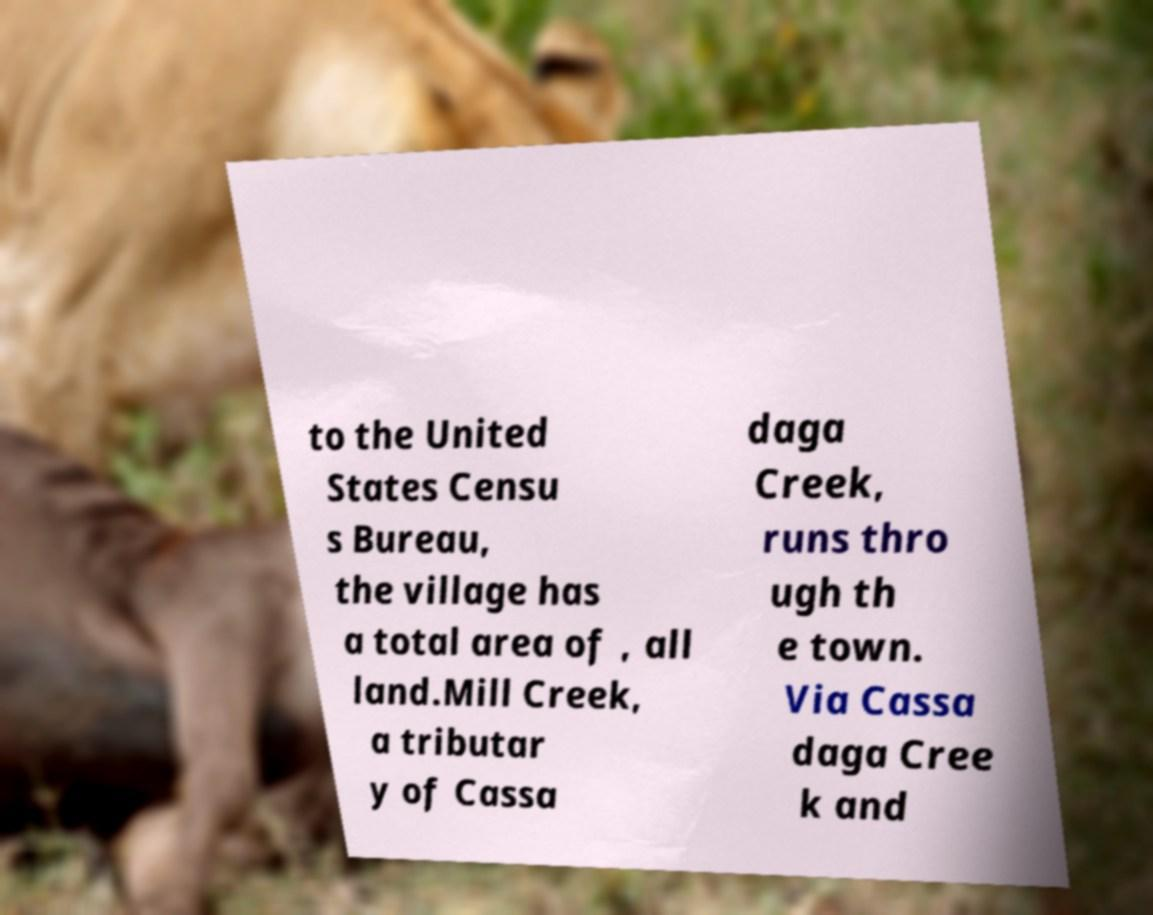Can you accurately transcribe the text from the provided image for me? to the United States Censu s Bureau, the village has a total area of , all land.Mill Creek, a tributar y of Cassa daga Creek, runs thro ugh th e town. Via Cassa daga Cree k and 